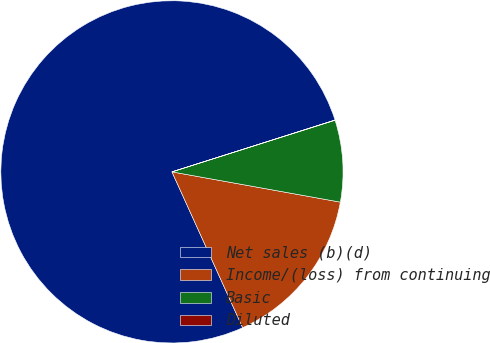Convert chart to OTSL. <chart><loc_0><loc_0><loc_500><loc_500><pie_chart><fcel>Net sales (b)(d)<fcel>Income/(loss) from continuing<fcel>Basic<fcel>Diluted<nl><fcel>76.88%<fcel>15.39%<fcel>7.71%<fcel>0.02%<nl></chart> 